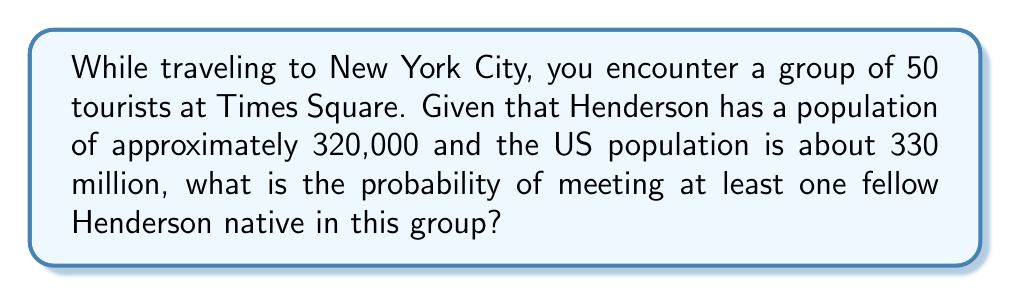Can you solve this math problem? Let's approach this step-by-step:

1) First, we need to calculate the probability of a random person in the US being from Henderson:
   $p = \frac{320,000}{330,000,000} \approx 0.000970$

2) The probability of a person not being from Henderson is:
   $q = 1 - p \approx 0.999030$

3) For there to be no Henderson natives in a group of 50, all 50 must not be from Henderson. The probability of this is:
   $q^{50} \approx (0.999030)^{50} \approx 0.952431$

4) Therefore, the probability of meeting at least one Henderson native is:
   $1 - q^{50} \approx 1 - 0.952431 \approx 0.047569$

5) To express this as a percentage:
   $0.047569 \times 100\% \approx 4.7569\%$
Answer: $4.76\%$ 